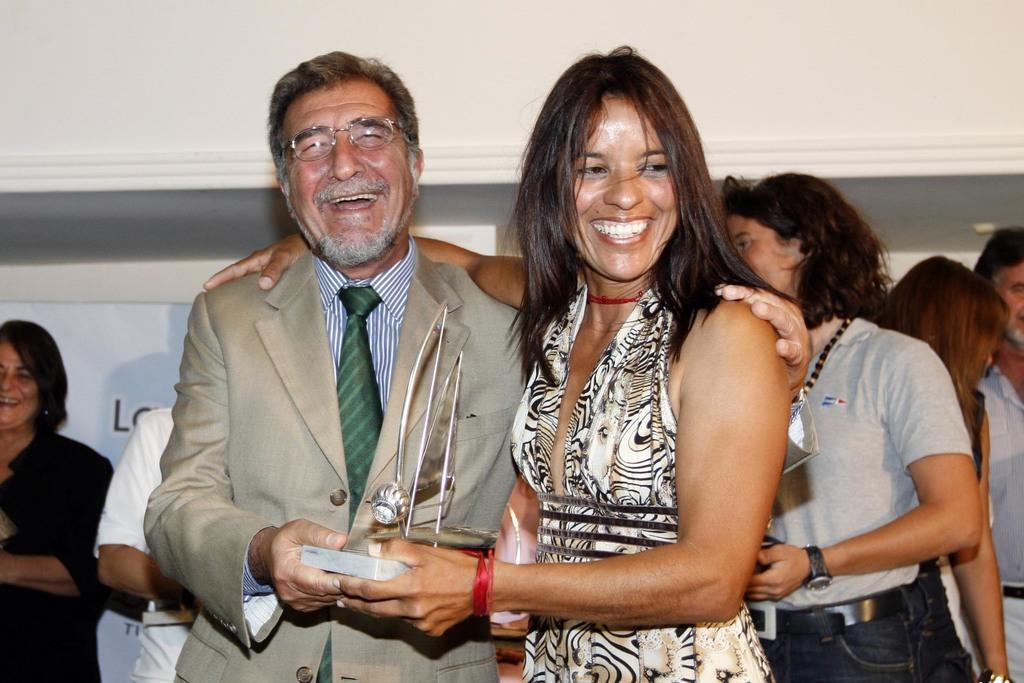How would you summarize this image in a sentence or two? In the center of the image we can see man and woman holding trophy. In the background we can see persons, advertisement and wall. 